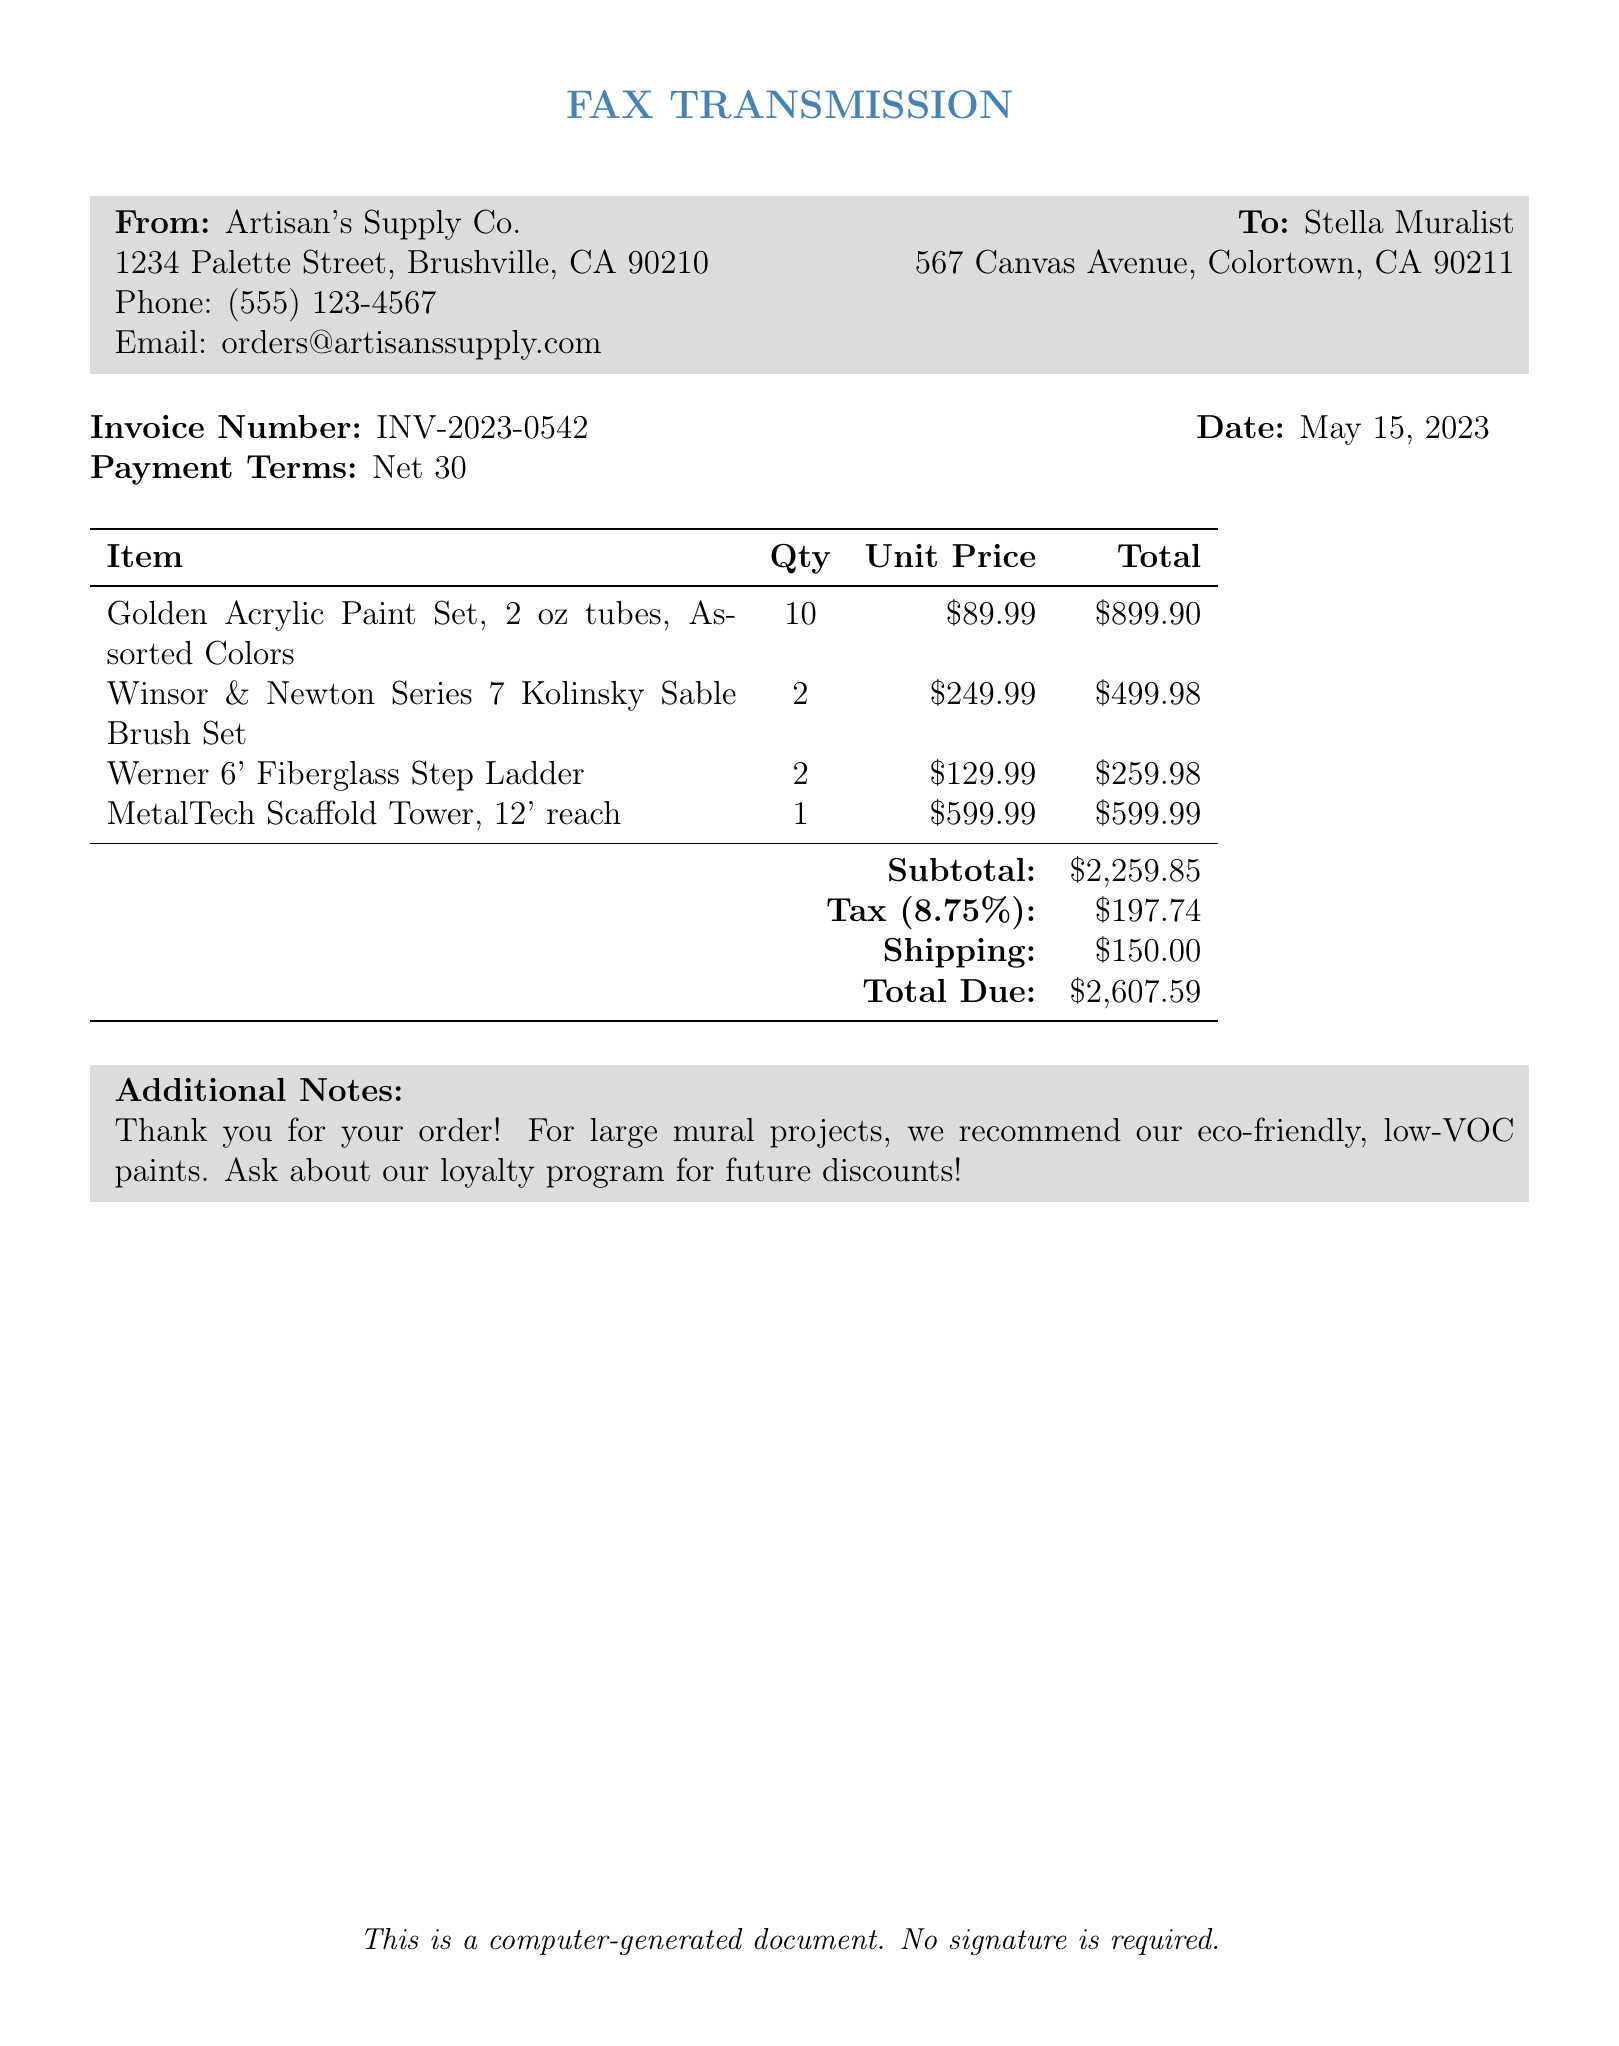what is the invoice number? The invoice number is clearly stated at the top of the document as a reference for the transaction.
Answer: INV-2023-0542 who is the sender of the fax? The sender of the fax is specified in the 'From' section of the document.
Answer: Artisan's Supply Co what is the total due amount? The document provides a summary of costs, including tax and shipping, resulting in the total due amount.
Answer: $2,607.59 how many Golden Acrylic Paint Sets were ordered? The quantity of Golden Acrylic Paint Sets is mentioned in the itemized list.
Answer: 10 what is the shipping cost? The shipping cost is outlined as a separate line item in the invoice summary.
Answer: $150.00 how much tax was applied to the order? The tax amount is provided in the summary section as a percentage of the subtotal.
Answer: $197.74 when was the invoice dated? The date of the invoice is explicitly indicated near the invoice number.
Answer: May 15, 2023 how many Winsor & Newton Series 7 Kolinsky Sable Brush Sets were purchased? The quantity of the brush sets is mentioned in the list of items ordered.
Answer: 2 what are the payment terms specified in the invoice? The payment terms are provided in the header section of the document.
Answer: Net 30 